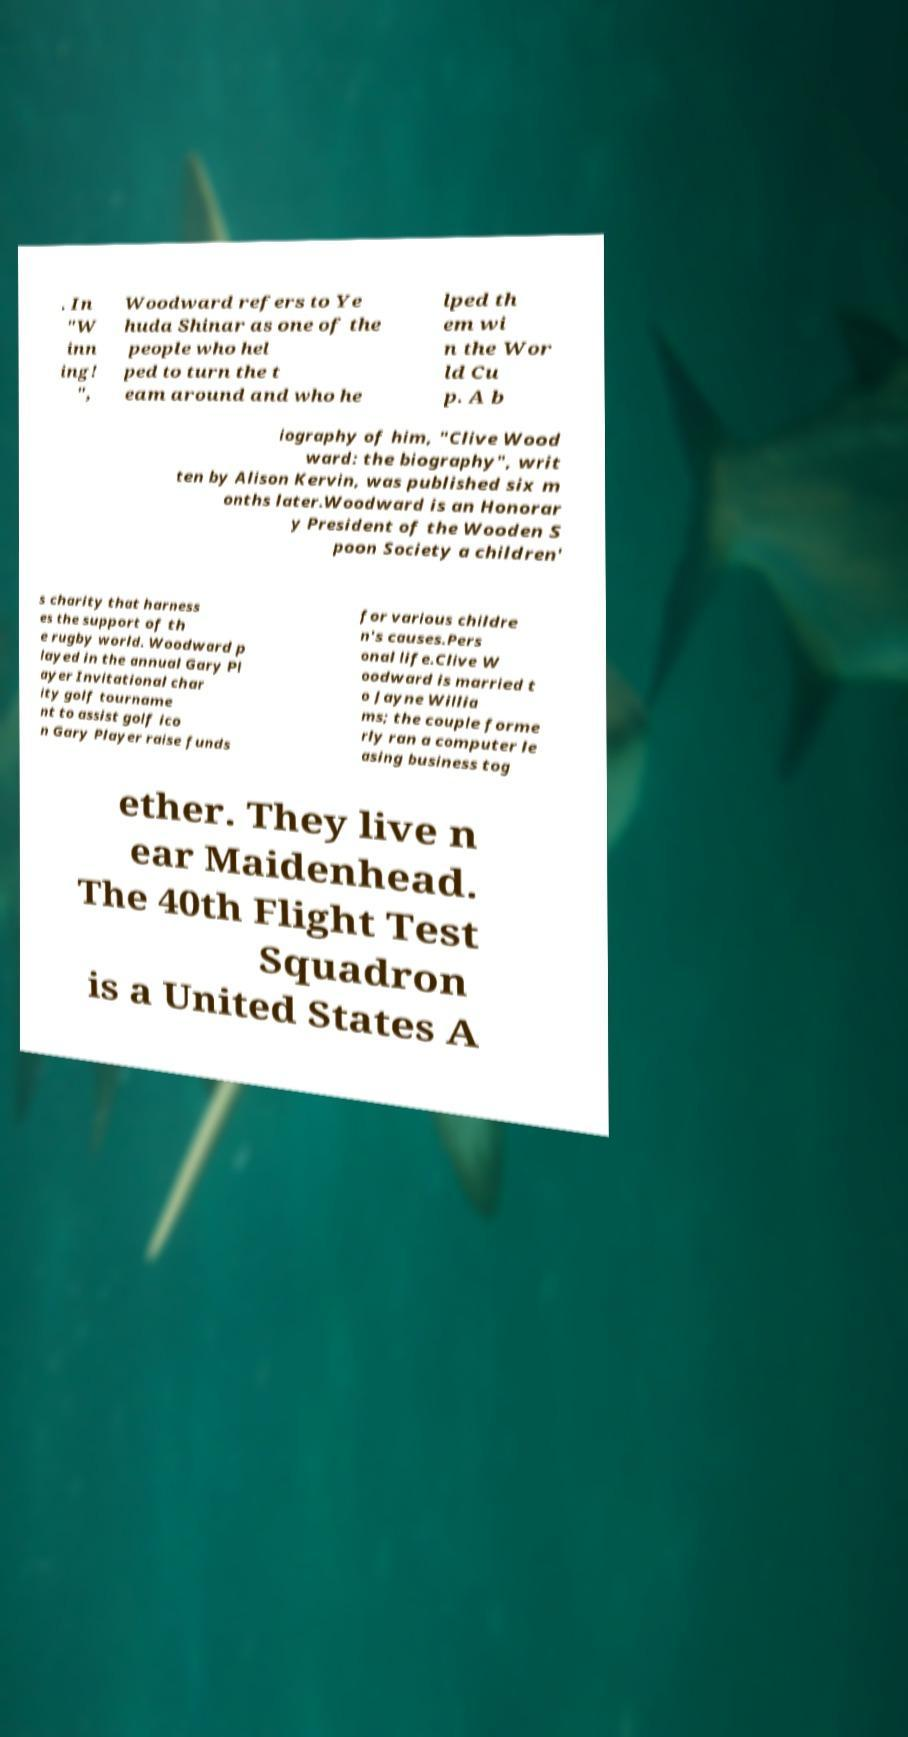For documentation purposes, I need the text within this image transcribed. Could you provide that? . In "W inn ing! ", Woodward refers to Ye huda Shinar as one of the people who hel ped to turn the t eam around and who he lped th em wi n the Wor ld Cu p. A b iography of him, "Clive Wood ward: the biography", writ ten by Alison Kervin, was published six m onths later.Woodward is an Honorar y President of the Wooden S poon Society a children' s charity that harness es the support of th e rugby world. Woodward p layed in the annual Gary Pl ayer Invitational char ity golf tourname nt to assist golf ico n Gary Player raise funds for various childre n's causes.Pers onal life.Clive W oodward is married t o Jayne Willia ms; the couple forme rly ran a computer le asing business tog ether. They live n ear Maidenhead. The 40th Flight Test Squadron is a United States A 